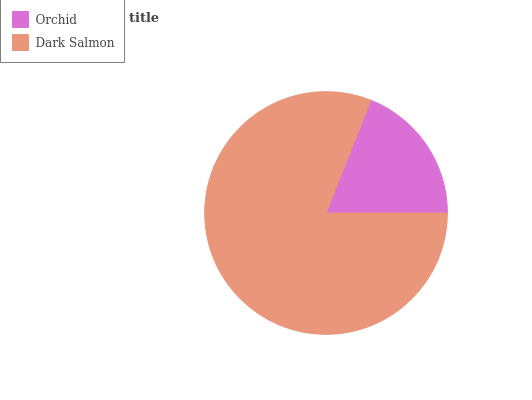Is Orchid the minimum?
Answer yes or no. Yes. Is Dark Salmon the maximum?
Answer yes or no. Yes. Is Dark Salmon the minimum?
Answer yes or no. No. Is Dark Salmon greater than Orchid?
Answer yes or no. Yes. Is Orchid less than Dark Salmon?
Answer yes or no. Yes. Is Orchid greater than Dark Salmon?
Answer yes or no. No. Is Dark Salmon less than Orchid?
Answer yes or no. No. Is Dark Salmon the high median?
Answer yes or no. Yes. Is Orchid the low median?
Answer yes or no. Yes. Is Orchid the high median?
Answer yes or no. No. Is Dark Salmon the low median?
Answer yes or no. No. 